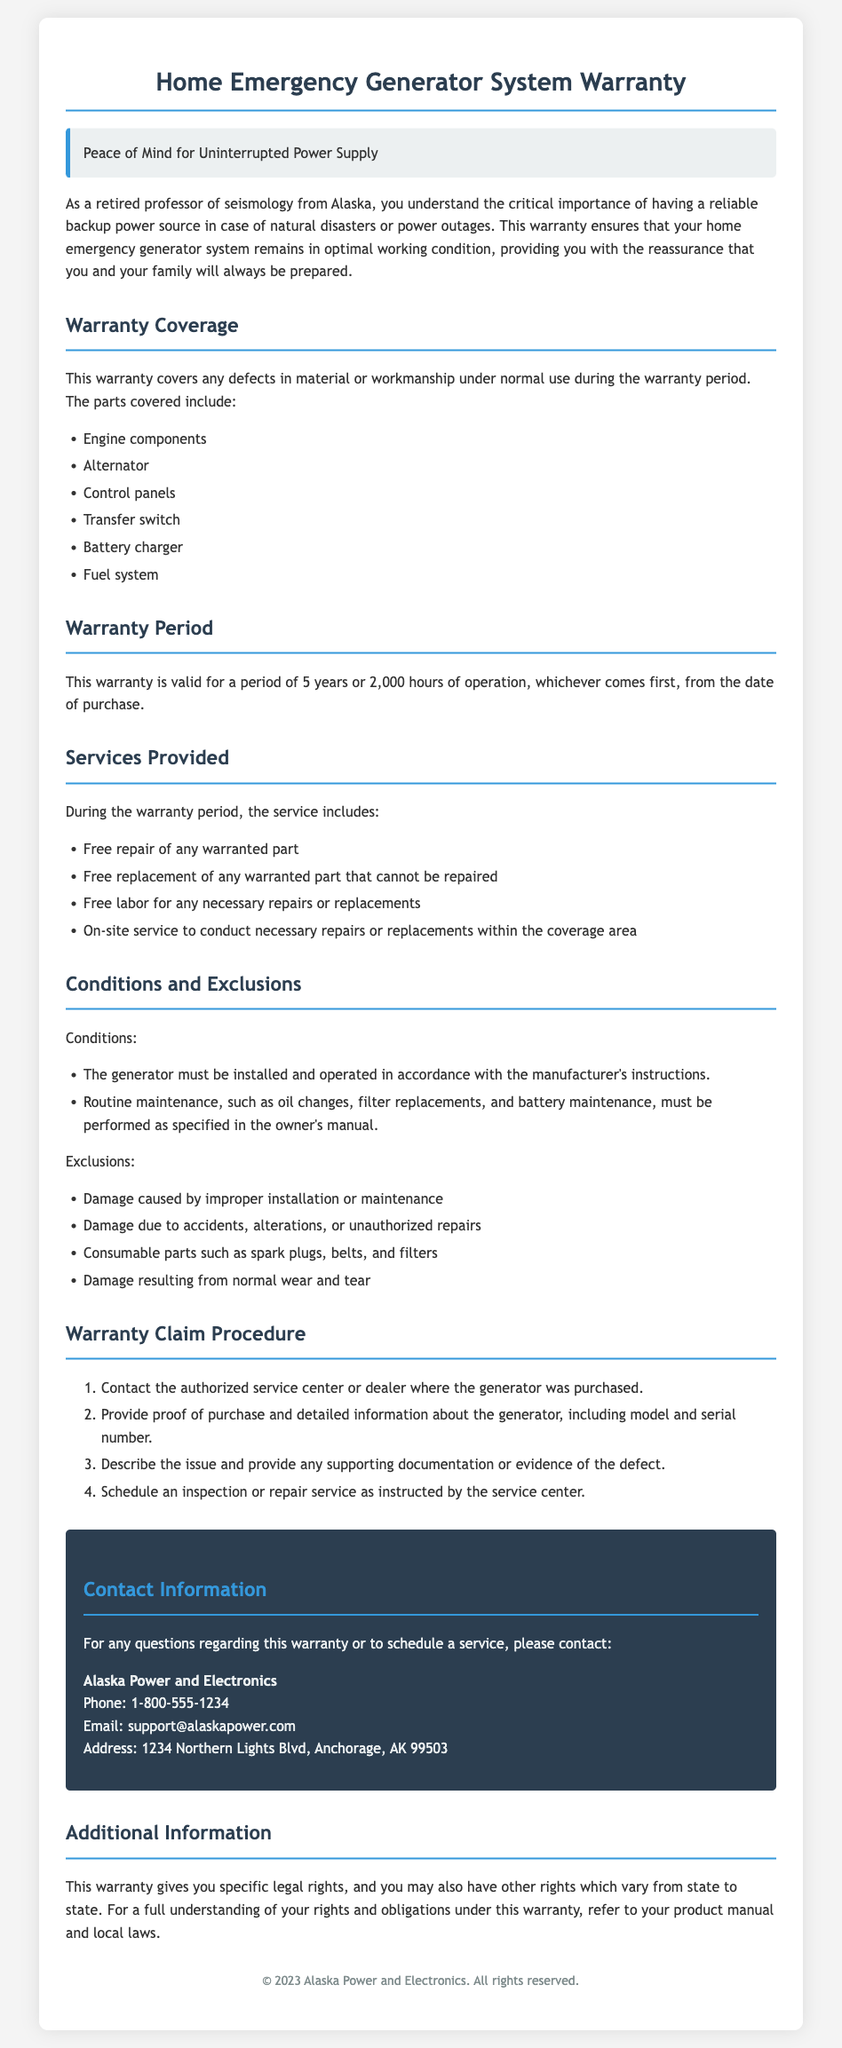What components are covered under the warranty? The warranty covers specific components as listed in the document, including engine components, alternator, control panels, transfer switch, battery charger, and fuel system.
Answer: Engine components, alternator, control panels, transfer switch, battery charger, fuel system What is the warranty period? The warranty is valid for a specified duration, which is clearly stated in the document as 5 years or 2,000 hours of operation, whichever comes first.
Answer: 5 years or 2,000 hours What type of service is included during the warranty period? The document lists the services provided during the warranty, including free repair of any warranted part and free labor for necessary repairs or replacements.
Answer: Free repair, free replacement, free labor, on-site service Which parts are excluded from the warranty? The document specifies several exclusions, including damage caused by improper installation, consumable parts like spark plugs, and damage from wear and tear.
Answer: Improper installation, accidents, consumable parts, normal wear and tear What is the first step in the warranty claim procedure? The document outlines a series of steps for the warranty claim procedure, starting with contacting the authorized service center or dealer where the generator was purchased.
Answer: Contact the authorized service center What is the contact phone number for warranty inquiries? The warranty document provides specific contact information for inquiries, including a phone number, which can be found in the contact information section.
Answer: 1-800-555-1234 What must be done to maintain warranty coverage? The document states conditions that must be met, specifically routine maintenance as outlined in the owner's manual, to ensure warranty coverage remains valid.
Answer: Routine maintenance How long is the warranty valid from the date of purchase? The document states the warranty is valid for a specified term which is stated in years or operational hours, providing clarity on its duration.
Answer: 5 years 